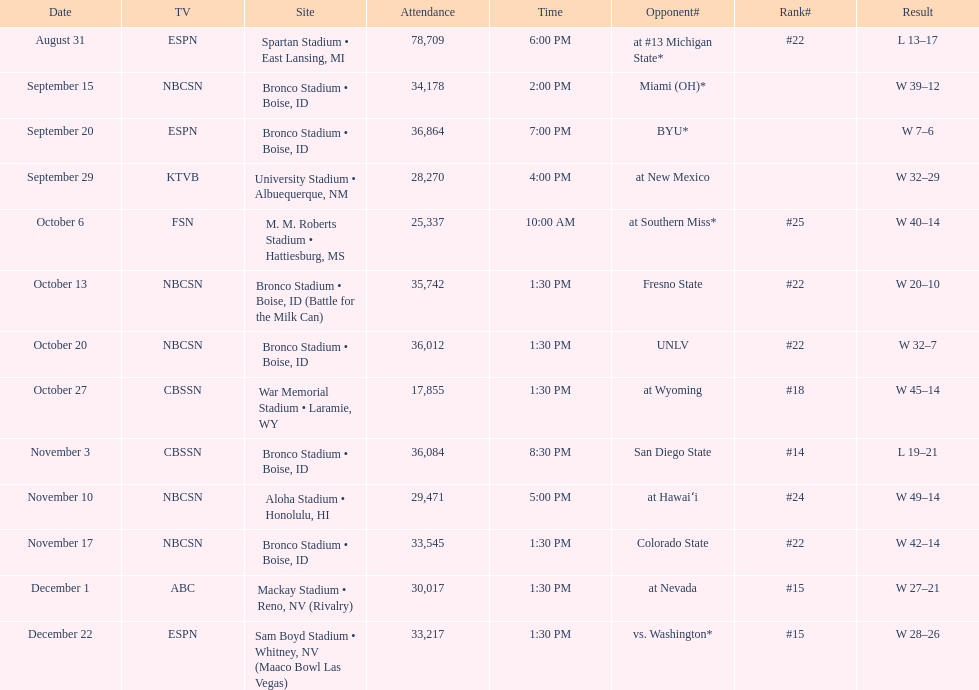Which team has the highest rank among those listed? San Diego State. 